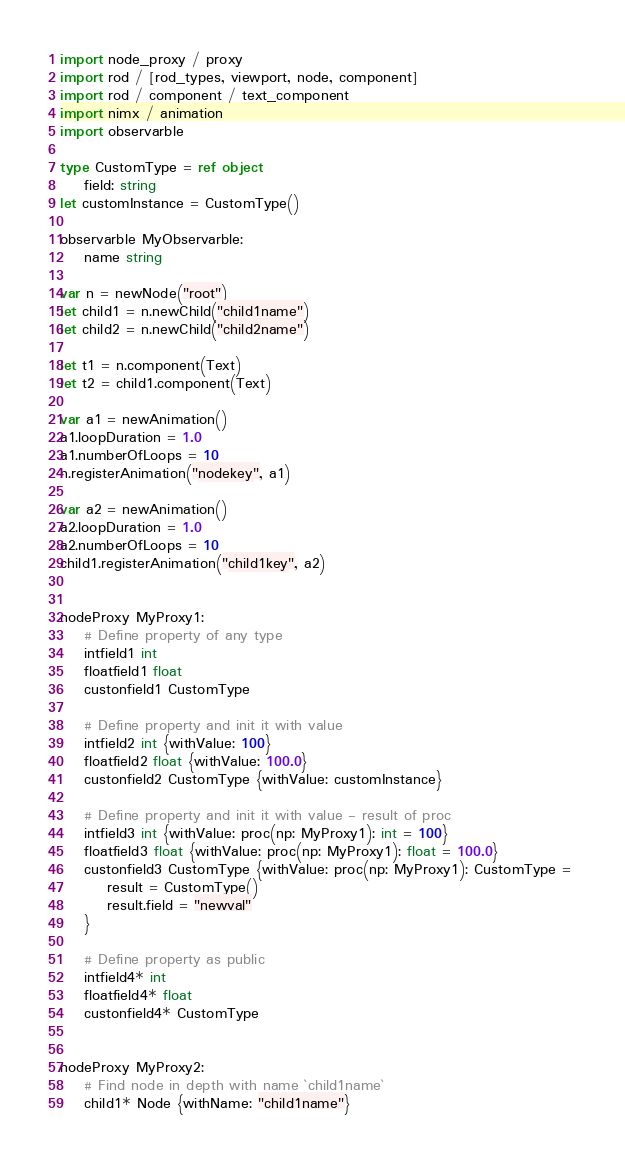<code> <loc_0><loc_0><loc_500><loc_500><_Nim_>import node_proxy / proxy
import rod / [rod_types, viewport, node, component]
import rod / component / text_component
import nimx / animation
import observarble

type CustomType = ref object
    field: string
let customInstance = CustomType()

observarble MyObservarble:
    name string

var n = newNode("root")
let child1 = n.newChild("child1name")
let child2 = n.newChild("child2name")

let t1 = n.component(Text)
let t2 = child1.component(Text)

var a1 = newAnimation()
a1.loopDuration = 1.0
a1.numberOfLoops = 10
n.registerAnimation("nodekey", a1)

var a2 = newAnimation()
a2.loopDuration = 1.0
a2.numberOfLoops = 10
child1.registerAnimation("child1key", a2)


nodeProxy MyProxy1:
    # Define property of any type
    intfield1 int
    floatfield1 float
    custonfield1 CustomType

    # Define property and init it with value
    intfield2 int {withValue: 100}
    floatfield2 float {withValue: 100.0}
    custonfield2 CustomType {withValue: customInstance}

    # Define property and init it with value - result of proc
    intfield3 int {withValue: proc(np: MyProxy1): int = 100}
    floatfield3 float {withValue: proc(np: MyProxy1): float = 100.0}
    custonfield3 CustomType {withValue: proc(np: MyProxy1): CustomType = 
        result = CustomType()
        result.field = "newval"
    }

    # Define property as public
    intfield4* int
    floatfield4* float
    custonfield4* CustomType


nodeProxy MyProxy2:
    # Find node in depth with name `child1name`
    child1* Node {withName: "child1name"}
</code> 